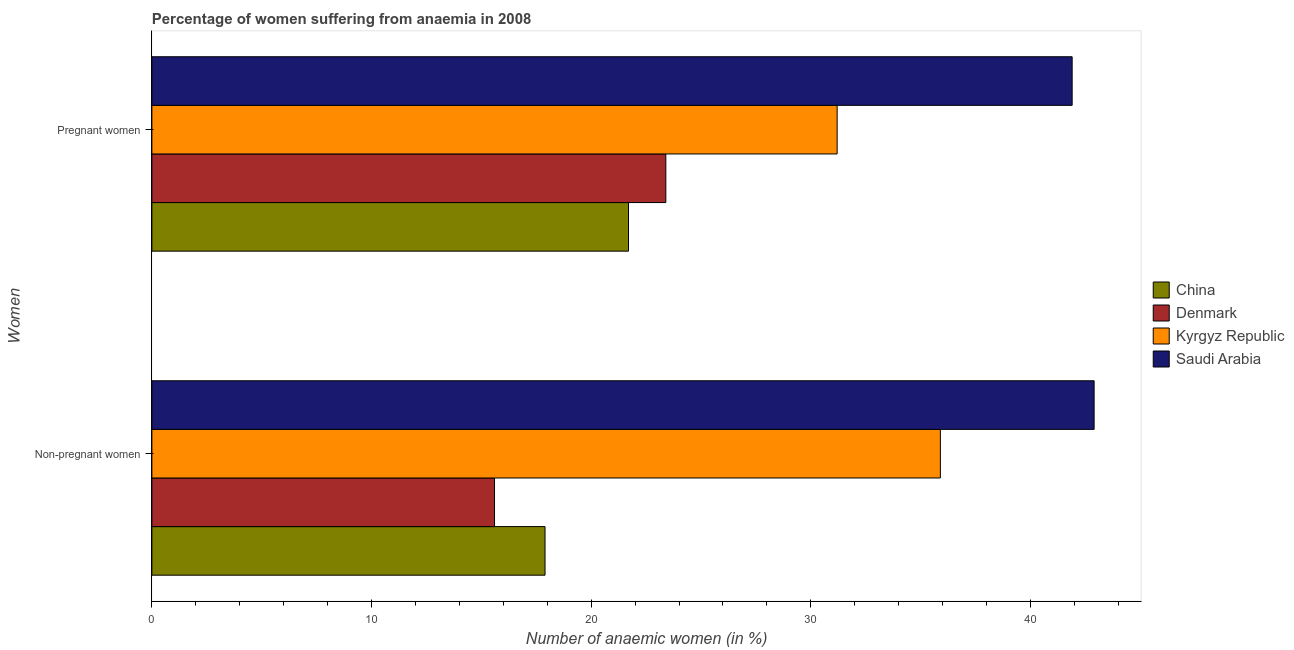How many groups of bars are there?
Provide a succinct answer. 2. Are the number of bars per tick equal to the number of legend labels?
Your answer should be compact. Yes. Are the number of bars on each tick of the Y-axis equal?
Keep it short and to the point. Yes. How many bars are there on the 2nd tick from the top?
Your answer should be very brief. 4. How many bars are there on the 1st tick from the bottom?
Your answer should be compact. 4. What is the label of the 1st group of bars from the top?
Keep it short and to the point. Pregnant women. Across all countries, what is the maximum percentage of pregnant anaemic women?
Keep it short and to the point. 41.9. Across all countries, what is the minimum percentage of non-pregnant anaemic women?
Provide a succinct answer. 15.6. In which country was the percentage of pregnant anaemic women maximum?
Provide a succinct answer. Saudi Arabia. What is the total percentage of non-pregnant anaemic women in the graph?
Offer a very short reply. 112.3. What is the difference between the percentage of pregnant anaemic women in Kyrgyz Republic and that in Denmark?
Offer a very short reply. 7.8. What is the average percentage of pregnant anaemic women per country?
Your answer should be compact. 29.55. What is the difference between the percentage of non-pregnant anaemic women and percentage of pregnant anaemic women in Saudi Arabia?
Provide a succinct answer. 1. In how many countries, is the percentage of pregnant anaemic women greater than 10 %?
Ensure brevity in your answer.  4. What is the ratio of the percentage of pregnant anaemic women in Kyrgyz Republic to that in China?
Provide a succinct answer. 1.44. In how many countries, is the percentage of non-pregnant anaemic women greater than the average percentage of non-pregnant anaemic women taken over all countries?
Make the answer very short. 2. How many bars are there?
Your response must be concise. 8. Are all the bars in the graph horizontal?
Make the answer very short. Yes. What is the difference between two consecutive major ticks on the X-axis?
Keep it short and to the point. 10. Are the values on the major ticks of X-axis written in scientific E-notation?
Your answer should be compact. No. Does the graph contain any zero values?
Keep it short and to the point. No. Does the graph contain grids?
Offer a terse response. No. What is the title of the graph?
Provide a short and direct response. Percentage of women suffering from anaemia in 2008. What is the label or title of the X-axis?
Provide a succinct answer. Number of anaemic women (in %). What is the label or title of the Y-axis?
Your answer should be very brief. Women. What is the Number of anaemic women (in %) of China in Non-pregnant women?
Offer a very short reply. 17.9. What is the Number of anaemic women (in %) in Denmark in Non-pregnant women?
Provide a short and direct response. 15.6. What is the Number of anaemic women (in %) of Kyrgyz Republic in Non-pregnant women?
Offer a terse response. 35.9. What is the Number of anaemic women (in %) in Saudi Arabia in Non-pregnant women?
Offer a terse response. 42.9. What is the Number of anaemic women (in %) of China in Pregnant women?
Provide a succinct answer. 21.7. What is the Number of anaemic women (in %) in Denmark in Pregnant women?
Your answer should be compact. 23.4. What is the Number of anaemic women (in %) in Kyrgyz Republic in Pregnant women?
Make the answer very short. 31.2. What is the Number of anaemic women (in %) of Saudi Arabia in Pregnant women?
Keep it short and to the point. 41.9. Across all Women, what is the maximum Number of anaemic women (in %) of China?
Give a very brief answer. 21.7. Across all Women, what is the maximum Number of anaemic women (in %) of Denmark?
Offer a terse response. 23.4. Across all Women, what is the maximum Number of anaemic women (in %) of Kyrgyz Republic?
Your answer should be very brief. 35.9. Across all Women, what is the maximum Number of anaemic women (in %) of Saudi Arabia?
Provide a short and direct response. 42.9. Across all Women, what is the minimum Number of anaemic women (in %) in China?
Your response must be concise. 17.9. Across all Women, what is the minimum Number of anaemic women (in %) of Kyrgyz Republic?
Give a very brief answer. 31.2. Across all Women, what is the minimum Number of anaemic women (in %) in Saudi Arabia?
Make the answer very short. 41.9. What is the total Number of anaemic women (in %) of China in the graph?
Your response must be concise. 39.6. What is the total Number of anaemic women (in %) in Kyrgyz Republic in the graph?
Give a very brief answer. 67.1. What is the total Number of anaemic women (in %) in Saudi Arabia in the graph?
Your response must be concise. 84.8. What is the difference between the Number of anaemic women (in %) in China in Non-pregnant women and that in Pregnant women?
Provide a short and direct response. -3.8. What is the difference between the Number of anaemic women (in %) of Denmark in Non-pregnant women and that in Pregnant women?
Keep it short and to the point. -7.8. What is the difference between the Number of anaemic women (in %) in China in Non-pregnant women and the Number of anaemic women (in %) in Denmark in Pregnant women?
Your answer should be very brief. -5.5. What is the difference between the Number of anaemic women (in %) of China in Non-pregnant women and the Number of anaemic women (in %) of Kyrgyz Republic in Pregnant women?
Keep it short and to the point. -13.3. What is the difference between the Number of anaemic women (in %) of China in Non-pregnant women and the Number of anaemic women (in %) of Saudi Arabia in Pregnant women?
Offer a very short reply. -24. What is the difference between the Number of anaemic women (in %) in Denmark in Non-pregnant women and the Number of anaemic women (in %) in Kyrgyz Republic in Pregnant women?
Your answer should be very brief. -15.6. What is the difference between the Number of anaemic women (in %) in Denmark in Non-pregnant women and the Number of anaemic women (in %) in Saudi Arabia in Pregnant women?
Offer a very short reply. -26.3. What is the average Number of anaemic women (in %) of China per Women?
Offer a terse response. 19.8. What is the average Number of anaemic women (in %) in Denmark per Women?
Make the answer very short. 19.5. What is the average Number of anaemic women (in %) in Kyrgyz Republic per Women?
Ensure brevity in your answer.  33.55. What is the average Number of anaemic women (in %) in Saudi Arabia per Women?
Your answer should be very brief. 42.4. What is the difference between the Number of anaemic women (in %) of Denmark and Number of anaemic women (in %) of Kyrgyz Republic in Non-pregnant women?
Make the answer very short. -20.3. What is the difference between the Number of anaemic women (in %) of Denmark and Number of anaemic women (in %) of Saudi Arabia in Non-pregnant women?
Make the answer very short. -27.3. What is the difference between the Number of anaemic women (in %) of Kyrgyz Republic and Number of anaemic women (in %) of Saudi Arabia in Non-pregnant women?
Provide a short and direct response. -7. What is the difference between the Number of anaemic women (in %) in China and Number of anaemic women (in %) in Kyrgyz Republic in Pregnant women?
Your answer should be compact. -9.5. What is the difference between the Number of anaemic women (in %) of China and Number of anaemic women (in %) of Saudi Arabia in Pregnant women?
Offer a very short reply. -20.2. What is the difference between the Number of anaemic women (in %) of Denmark and Number of anaemic women (in %) of Kyrgyz Republic in Pregnant women?
Offer a very short reply. -7.8. What is the difference between the Number of anaemic women (in %) in Denmark and Number of anaemic women (in %) in Saudi Arabia in Pregnant women?
Offer a very short reply. -18.5. What is the difference between the Number of anaemic women (in %) in Kyrgyz Republic and Number of anaemic women (in %) in Saudi Arabia in Pregnant women?
Your answer should be very brief. -10.7. What is the ratio of the Number of anaemic women (in %) in China in Non-pregnant women to that in Pregnant women?
Offer a very short reply. 0.82. What is the ratio of the Number of anaemic women (in %) of Kyrgyz Republic in Non-pregnant women to that in Pregnant women?
Offer a very short reply. 1.15. What is the ratio of the Number of anaemic women (in %) in Saudi Arabia in Non-pregnant women to that in Pregnant women?
Your answer should be compact. 1.02. What is the difference between the highest and the second highest Number of anaemic women (in %) in Kyrgyz Republic?
Your answer should be very brief. 4.7. What is the difference between the highest and the lowest Number of anaemic women (in %) in Saudi Arabia?
Offer a terse response. 1. 